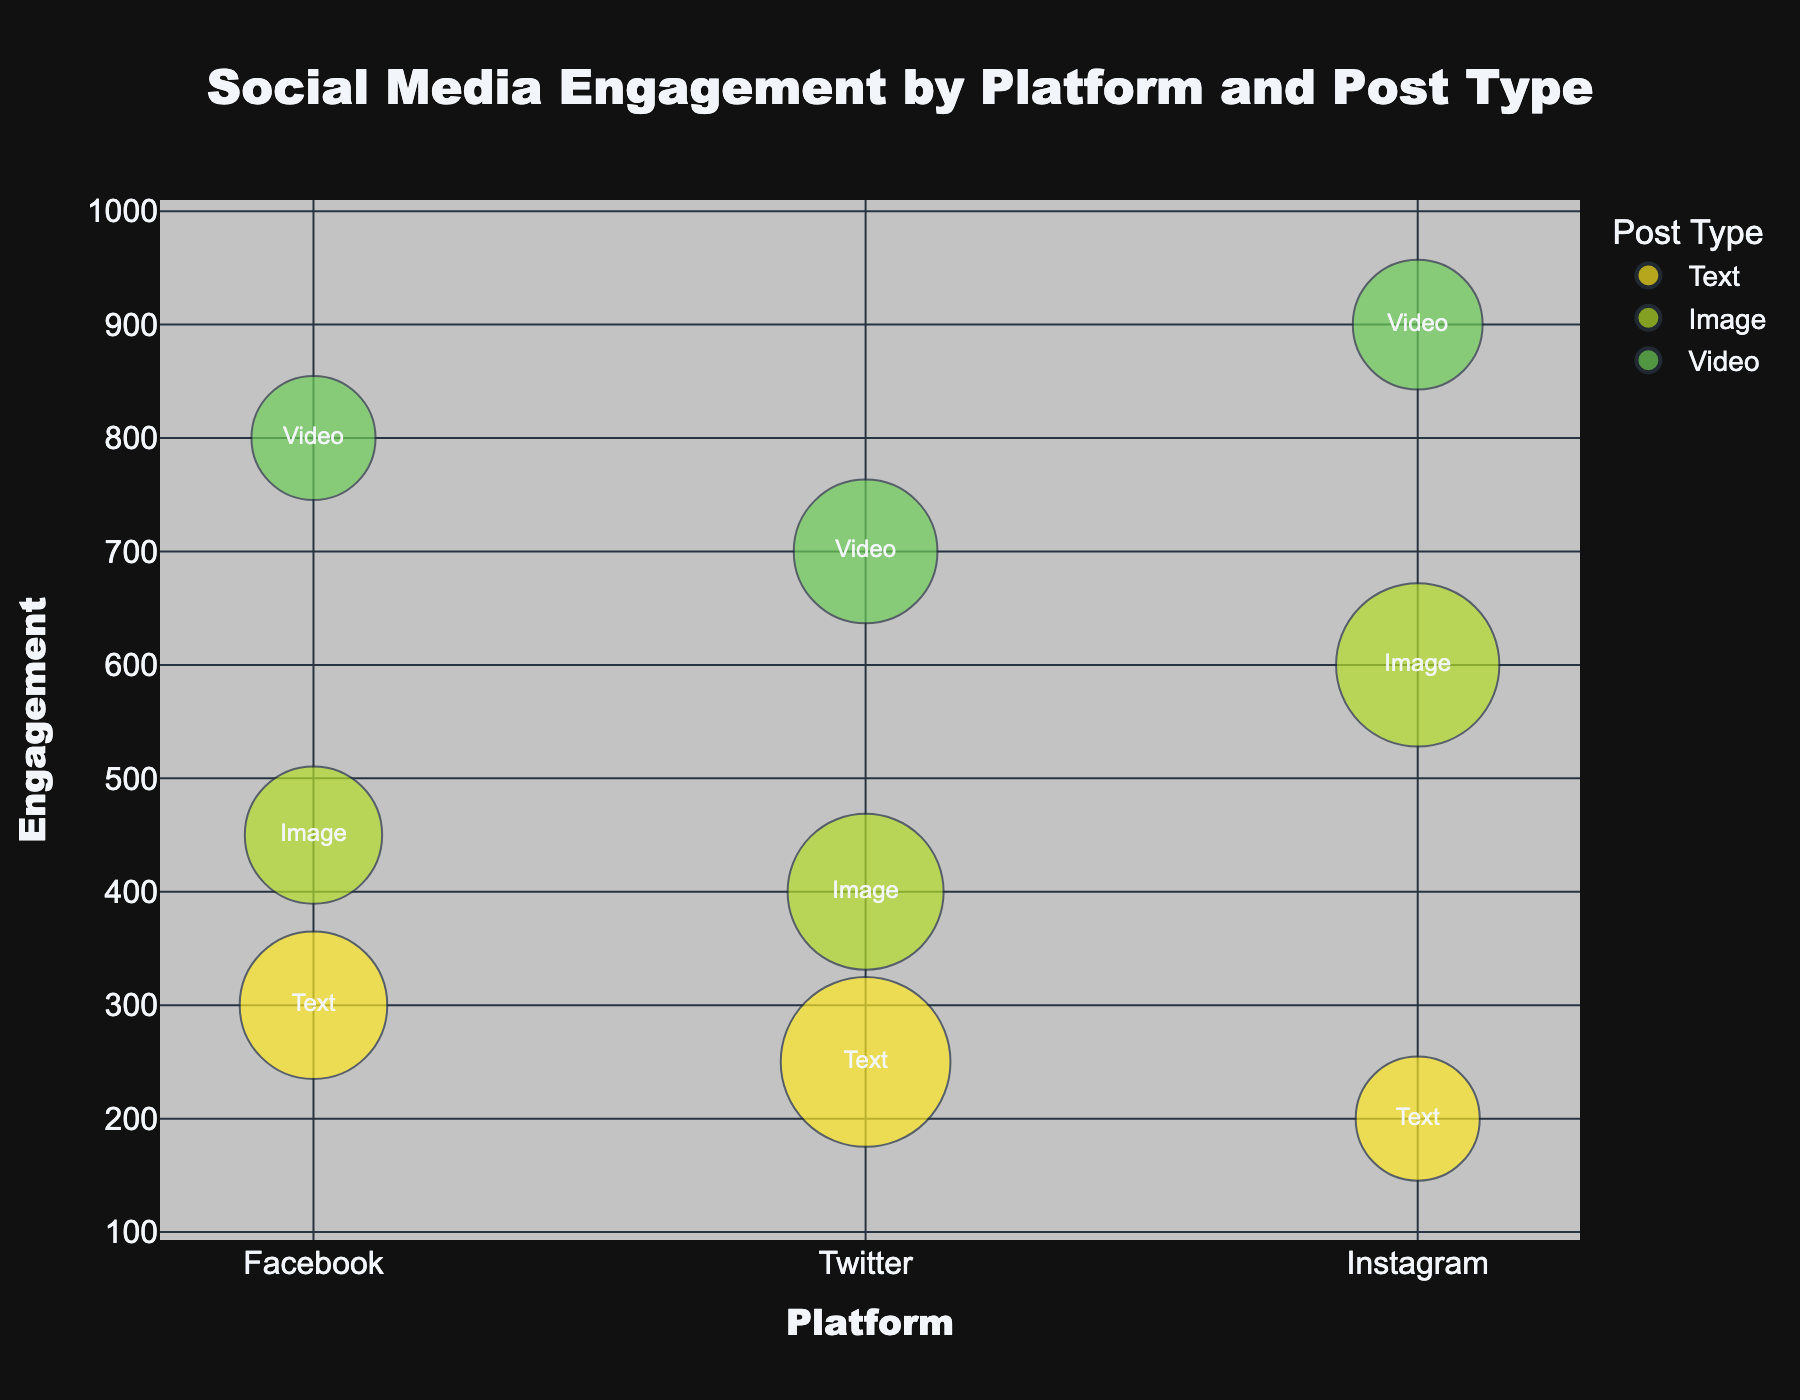What is the title of the chart? The title of the chart is displayed prominently at the top of the figure. It provides a summary of what the chart represents.
Answer: Social Media Engagement by Platform and Post Type Which platform has the highest engagement for video posts? Looking at the y-axis labeled "Engagement," the highest data point for video posts (typically a bubble labeled "Video") corresponds to the platform labeled on the x-axis. The largest engagement value for video posts is clustered under the "Instagram" platform.
Answer: Instagram How many data points are represented in the chart? Each bubble represents a unique combination of platform and post type. Count the number of these combinations or bubbles seen in the chart.
Answer: 9 What is the average engagement for text posts across all platforms? First, identify the y-values (engagement values) for text posts on each platform. These values are 300 (Facebook), 250 (Twitter), and 200 (Instagram). Sum these values and divide by the number of text posts to get the average. (300 + 250 + 200) / 3 = 750 / 3
Answer: 250 What is the total post count for image posts on all platforms? Locate the bubble sizes for image posts on each platform and sum them up. The post counts are 15 (Facebook), 25 (Twitter), and 30 (Instagram). Total post count is 15 + 25 + 30
Answer: 70 Which post type has the greatest engagement on Facebook and by how much does it exceed the others? Compare the engagement values for each post type (text, image, video) on Facebook by looking at the bubbles labeled "Text," "Image," and "Video" under the "Facebook" platform. Video has the highest value of 800. Next highest are image (450) and text (300). Video engagement exceeds image by 800 - 450 = 350 and text by 800 - 300 = 500.
Answer: Video, by 350 and 500 Which platform has the lowest average engagement across all post types? Calculate the average engagement for each platform by summing their respective engagement values and dividing by the number of post types (3 each). For Facebook: (300 + 450 + 800) / 3 = 1550 / 3 = 516.67, for Twitter: (250 + 400 + 700) / 3 = 1350 / 3 = 450, for Instagram: (200 + 600 + 900) / 3 = 1700 / 3 = 566.67. The platform with the lowest average engagement is Twitter.
Answer: Twitter Which platform has the smallest bubble for video posts, and what is its post count? Examine the bubbles for video post types and identify the smallest one by comparing their sizes. The smallest bubble corresponds to Twitter. The custom data indicates a post count of 18 for Twitter video posts.
Answer: Twitter, 18 